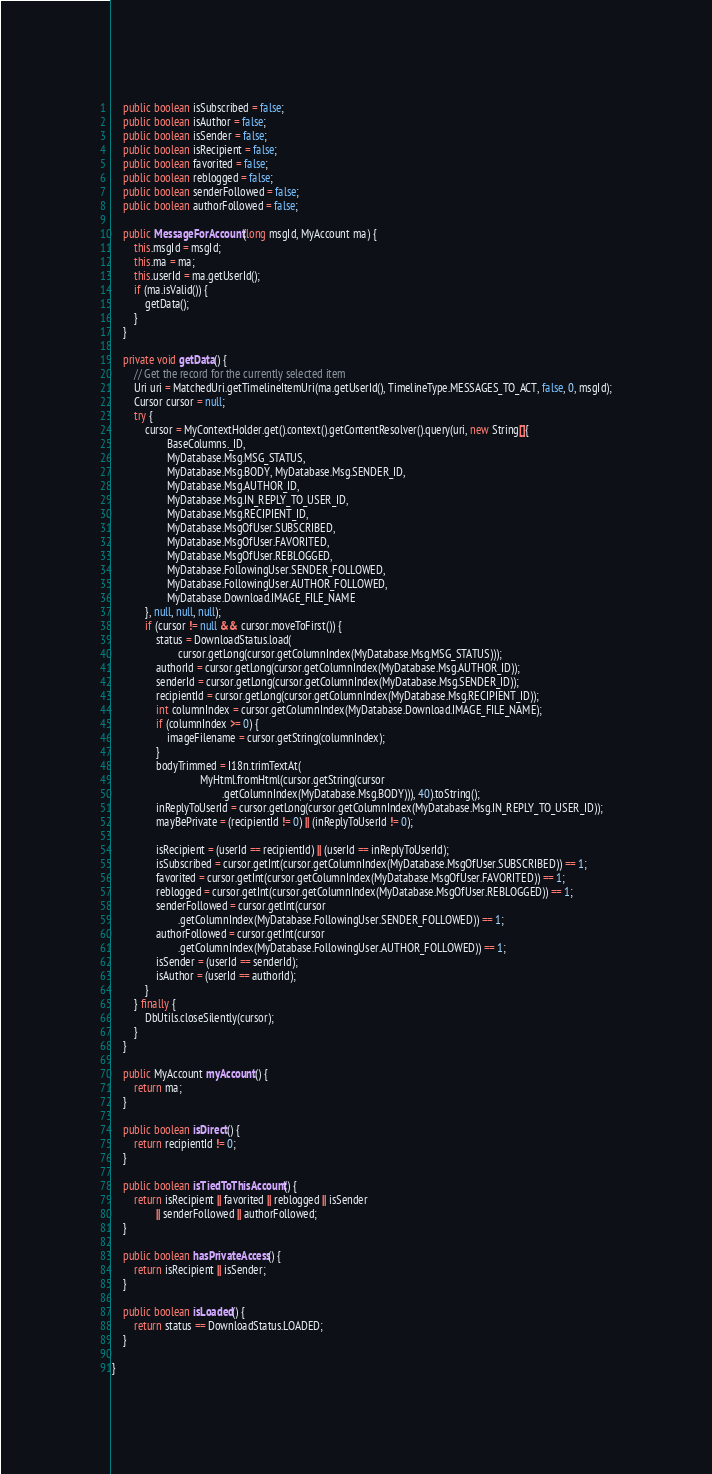Convert code to text. <code><loc_0><loc_0><loc_500><loc_500><_Java_>    public boolean isSubscribed = false;
    public boolean isAuthor = false;
    public boolean isSender = false;
    public boolean isRecipient = false;
    public boolean favorited = false;
    public boolean reblogged = false;
    public boolean senderFollowed = false;
    public boolean authorFollowed = false;
    
    public MessageForAccount(long msgId, MyAccount ma) {
        this.msgId = msgId;
        this.ma = ma;
        this.userId = ma.getUserId();
        if (ma.isValid()) {
            getData();
        }
    }

    private void getData() {
        // Get the record for the currently selected item
        Uri uri = MatchedUri.getTimelineItemUri(ma.getUserId(), TimelineType.MESSAGES_TO_ACT, false, 0, msgId);
        Cursor cursor = null;
        try {
            cursor = MyContextHolder.get().context().getContentResolver().query(uri, new String[]{
                    BaseColumns._ID,
                    MyDatabase.Msg.MSG_STATUS,
                    MyDatabase.Msg.BODY, MyDatabase.Msg.SENDER_ID,
                    MyDatabase.Msg.AUTHOR_ID,
                    MyDatabase.Msg.IN_REPLY_TO_USER_ID,
                    MyDatabase.Msg.RECIPIENT_ID,
                    MyDatabase.MsgOfUser.SUBSCRIBED,
                    MyDatabase.MsgOfUser.FAVORITED,
                    MyDatabase.MsgOfUser.REBLOGGED,
                    MyDatabase.FollowingUser.SENDER_FOLLOWED,
                    MyDatabase.FollowingUser.AUTHOR_FOLLOWED,
                    MyDatabase.Download.IMAGE_FILE_NAME
            }, null, null, null);
            if (cursor != null && cursor.moveToFirst()) {
                status = DownloadStatus.load(
                        cursor.getLong(cursor.getColumnIndex(MyDatabase.Msg.MSG_STATUS)));
                authorId = cursor.getLong(cursor.getColumnIndex(MyDatabase.Msg.AUTHOR_ID));
                senderId = cursor.getLong(cursor.getColumnIndex(MyDatabase.Msg.SENDER_ID));
                recipientId = cursor.getLong(cursor.getColumnIndex(MyDatabase.Msg.RECIPIENT_ID));
                int columnIndex = cursor.getColumnIndex(MyDatabase.Download.IMAGE_FILE_NAME);
                if (columnIndex >= 0) {
                    imageFilename = cursor.getString(columnIndex);
                }
                bodyTrimmed = I18n.trimTextAt(
                                MyHtml.fromHtml(cursor.getString(cursor
                                        .getColumnIndex(MyDatabase.Msg.BODY))), 40).toString();
                inReplyToUserId = cursor.getLong(cursor.getColumnIndex(MyDatabase.Msg.IN_REPLY_TO_USER_ID));
                mayBePrivate = (recipientId != 0) || (inReplyToUserId != 0);
                
                isRecipient = (userId == recipientId) || (userId == inReplyToUserId);
                isSubscribed = cursor.getInt(cursor.getColumnIndex(MyDatabase.MsgOfUser.SUBSCRIBED)) == 1;
                favorited = cursor.getInt(cursor.getColumnIndex(MyDatabase.MsgOfUser.FAVORITED)) == 1;
                reblogged = cursor.getInt(cursor.getColumnIndex(MyDatabase.MsgOfUser.REBLOGGED)) == 1;
                senderFollowed = cursor.getInt(cursor
                        .getColumnIndex(MyDatabase.FollowingUser.SENDER_FOLLOWED)) == 1;
                authorFollowed = cursor.getInt(cursor
                        .getColumnIndex(MyDatabase.FollowingUser.AUTHOR_FOLLOWED)) == 1;
                isSender = (userId == senderId);
                isAuthor = (userId == authorId);
            }
        } finally {
            DbUtils.closeSilently(cursor);
        }
    }

    public MyAccount myAccount() {
        return ma;
    }
    
    public boolean isDirect() {
        return recipientId != 0;
    }

    public boolean isTiedToThisAccount() {
        return isRecipient || favorited || reblogged || isSender
                || senderFollowed || authorFollowed;
    }

    public boolean hasPrivateAccess() {
        return isRecipient || isSender;
    }

    public boolean isLoaded() {
        return status == DownloadStatus.LOADED;
    }

}
</code> 